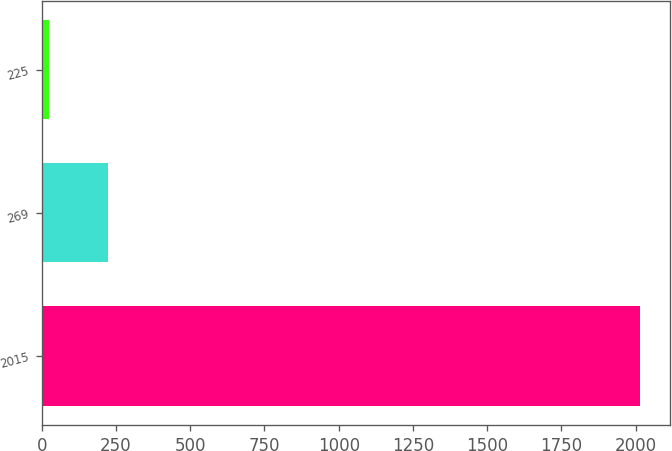Convert chart to OTSL. <chart><loc_0><loc_0><loc_500><loc_500><bar_chart><fcel>2015<fcel>269<fcel>225<nl><fcel>2014<fcel>222.64<fcel>23.6<nl></chart> 